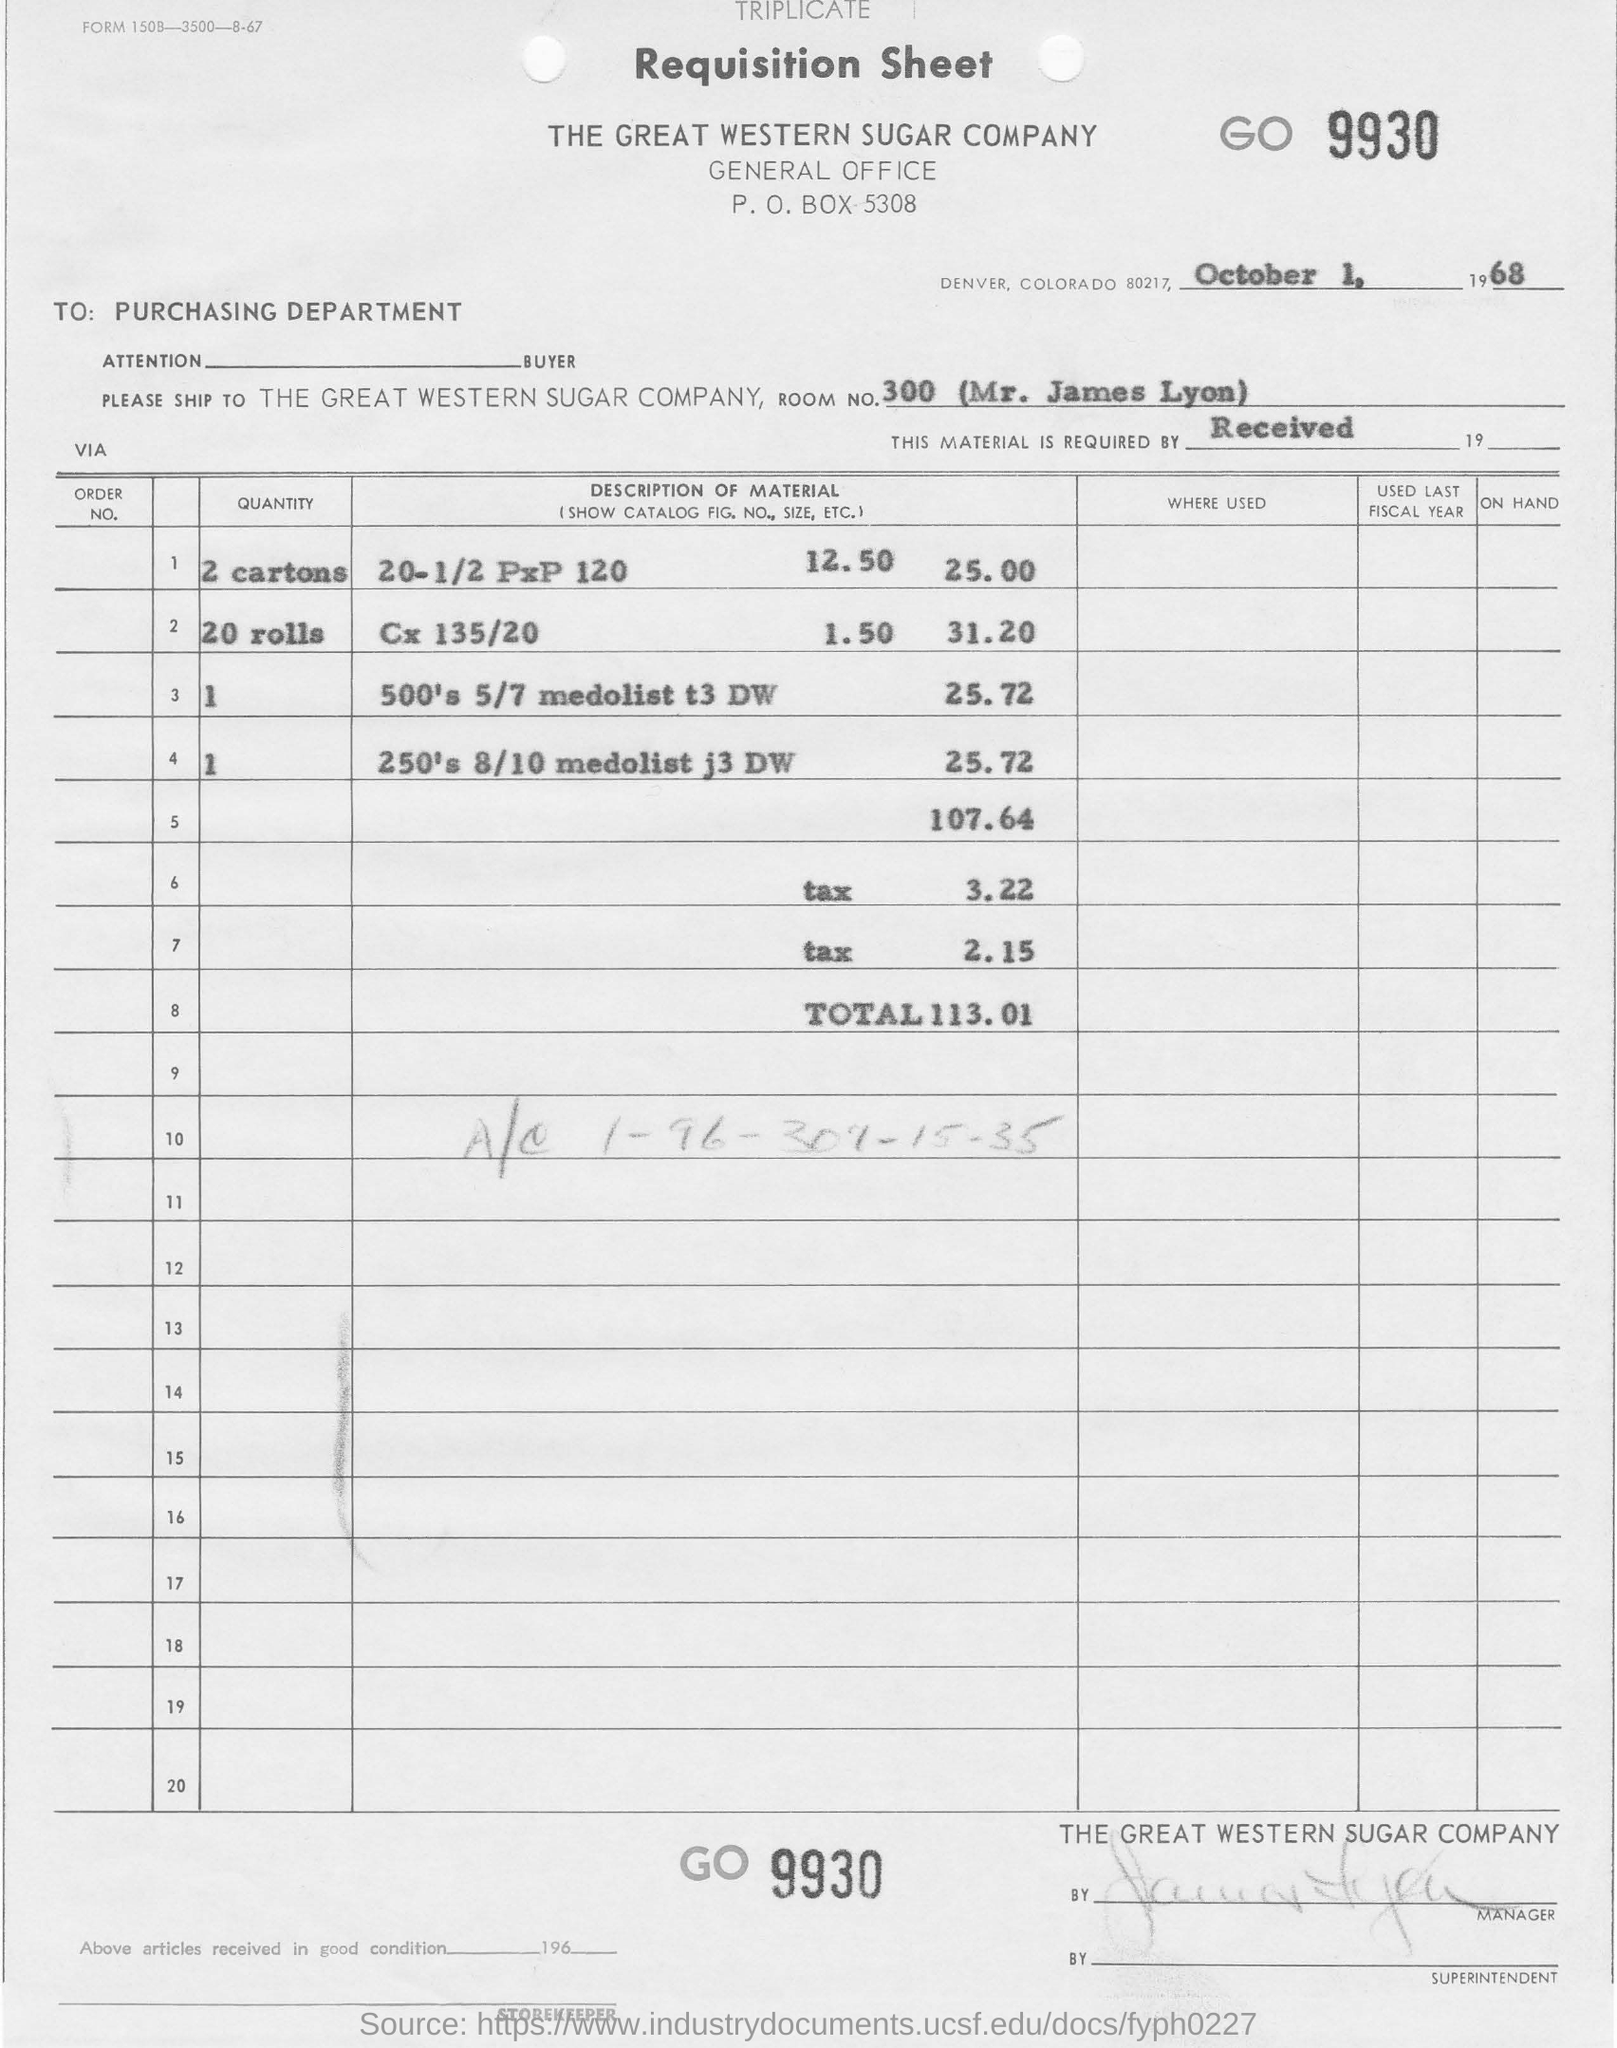What is the date on requisition sheet ?
Your answer should be very brief. October 1, 1968. What is the room no mentioned in the sheet?
Provide a succinct answer. 300. 